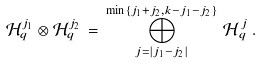<formula> <loc_0><loc_0><loc_500><loc_500>\mathcal { H } _ { q } ^ { j _ { 1 } } \otimes \mathcal { H } _ { q } ^ { j _ { 2 } } \, = \, \bigoplus _ { j = \left | { j _ { 1 } - j _ { 2 } } \right | } ^ { \min \left \{ j _ { 1 } + j _ { 2 } , k - j _ { 1 } - j _ { 2 } \right \} } \, \mathcal { H } _ { \, q } ^ { \, j } \, .</formula> 